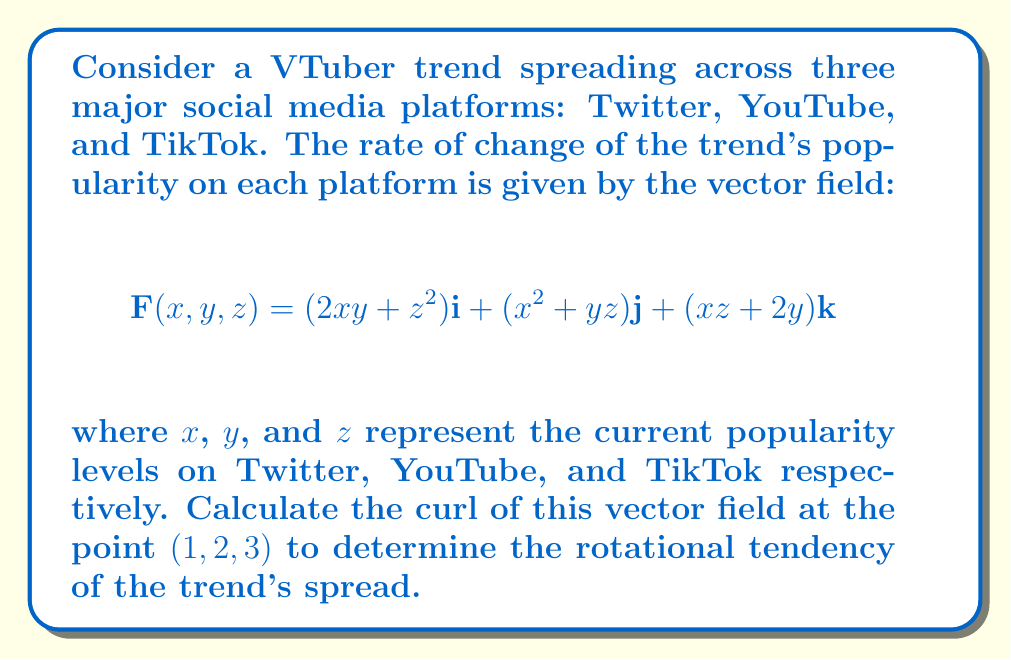Show me your answer to this math problem. To solve this problem, we need to calculate the curl of the vector field $\mathbf{F}$ at the point $(1, 2, 3)$. The curl is defined as:

$$\text{curl }\mathbf{F} = \nabla \times \mathbf{F} = \left(\frac{\partial F_z}{\partial y} - \frac{\partial F_y}{\partial z}\right)\mathbf{i} + \left(\frac{\partial F_x}{\partial z} - \frac{\partial F_z}{\partial x}\right)\mathbf{j} + \left(\frac{\partial F_y}{\partial x} - \frac{\partial F_x}{\partial y}\right)\mathbf{k}$$

Let's break it down step by step:

1) First, we need to find the partial derivatives:

   $\frac{\partial F_z}{\partial y} = 2$
   $\frac{\partial F_y}{\partial z} = y$
   $\frac{\partial F_x}{\partial z} = 2z$
   $\frac{\partial F_z}{\partial x} = z$
   $\frac{\partial F_y}{\partial x} = 2x$
   $\frac{\partial F_x}{\partial y} = 2x$

2) Now, let's substitute these into the curl formula:

   $\text{curl }\mathbf{F} = (2 - y)\mathbf{i} + (2z - z)\mathbf{j} + (2x - 2x)\mathbf{k}$

3) Simplify:

   $\text{curl }\mathbf{F} = (2 - y)\mathbf{i} + z\mathbf{j} + 0\mathbf{k}$

4) Now, we need to evaluate this at the point $(1, 2, 3)$:

   $\text{curl }\mathbf{F}(1, 2, 3) = (2 - 2)\mathbf{i} + 3\mathbf{j} + 0\mathbf{k}$

5) Final simplification:

   $\text{curl }\mathbf{F}(1, 2, 3) = 3\mathbf{j}$

This result indicates that at the point $(1, 2, 3)$, the VTuber trend has a rotational tendency primarily in the $y$ direction (YouTube), with a magnitude of 3.
Answer: $3\mathbf{j}$ 